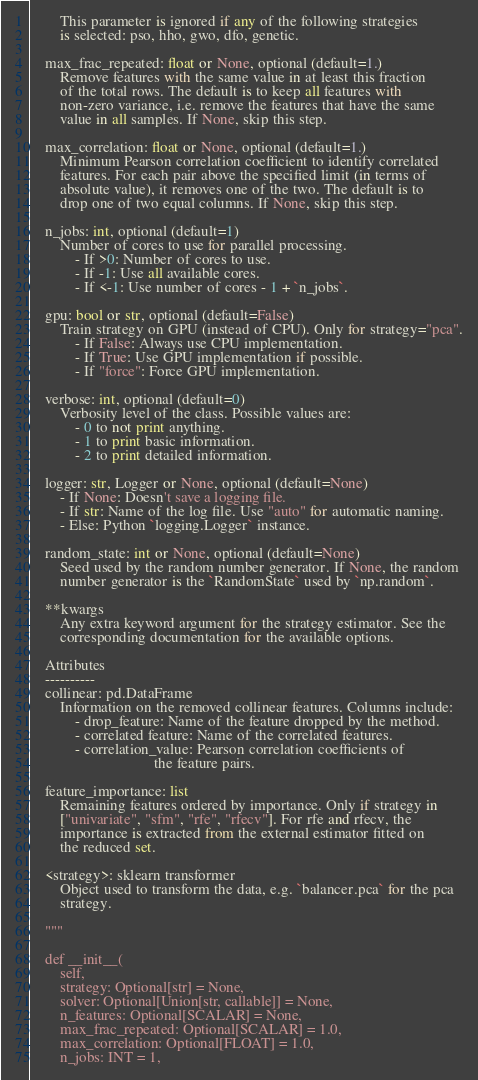Convert code to text. <code><loc_0><loc_0><loc_500><loc_500><_Python_>        This parameter is ignored if any of the following strategies
        is selected: pso, hho, gwo, dfo, genetic.

    max_frac_repeated: float or None, optional (default=1.)
        Remove features with the same value in at least this fraction
        of the total rows. The default is to keep all features with
        non-zero variance, i.e. remove the features that have the same
        value in all samples. If None, skip this step.

    max_correlation: float or None, optional (default=1.)
        Minimum Pearson correlation coefficient to identify correlated
        features. For each pair above the specified limit (in terms of
        absolute value), it removes one of the two. The default is to
        drop one of two equal columns. If None, skip this step.

    n_jobs: int, optional (default=1)
        Number of cores to use for parallel processing.
            - If >0: Number of cores to use.
            - If -1: Use all available cores.
            - If <-1: Use number of cores - 1 + `n_jobs`.

    gpu: bool or str, optional (default=False)
        Train strategy on GPU (instead of CPU). Only for strategy="pca".
            - If False: Always use CPU implementation.
            - If True: Use GPU implementation if possible.
            - If "force": Force GPU implementation.

    verbose: int, optional (default=0)
        Verbosity level of the class. Possible values are:
            - 0 to not print anything.
            - 1 to print basic information.
            - 2 to print detailed information.

    logger: str, Logger or None, optional (default=None)
        - If None: Doesn't save a logging file.
        - If str: Name of the log file. Use "auto" for automatic naming.
        - Else: Python `logging.Logger` instance.

    random_state: int or None, optional (default=None)
        Seed used by the random number generator. If None, the random
        number generator is the `RandomState` used by `np.random`.

    **kwargs
        Any extra keyword argument for the strategy estimator. See the
        corresponding documentation for the available options.

    Attributes
    ----------
    collinear: pd.DataFrame
        Information on the removed collinear features. Columns include:
            - drop_feature: Name of the feature dropped by the method.
            - correlated feature: Name of the correlated features.
            - correlation_value: Pearson correlation coefficients of
                                 the feature pairs.

    feature_importance: list
        Remaining features ordered by importance. Only if strategy in
        ["univariate", "sfm", "rfe", "rfecv"]. For rfe and rfecv, the
        importance is extracted from the external estimator fitted on
        the reduced set.

    <strategy>: sklearn transformer
        Object used to transform the data, e.g. `balancer.pca` for the pca
        strategy.

    """

    def __init__(
        self,
        strategy: Optional[str] = None,
        solver: Optional[Union[str, callable]] = None,
        n_features: Optional[SCALAR] = None,
        max_frac_repeated: Optional[SCALAR] = 1.0,
        max_correlation: Optional[FLOAT] = 1.0,
        n_jobs: INT = 1,</code> 